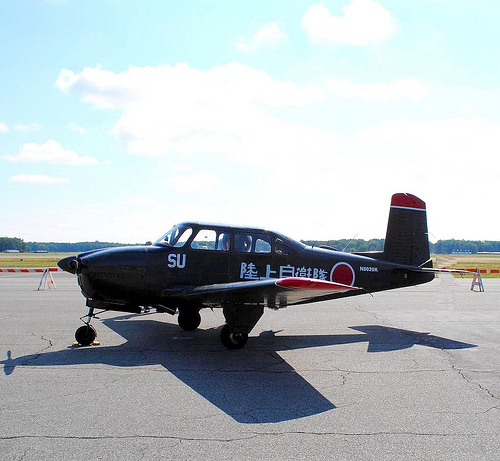Can you describe what you see in the image? This image depicts a small aircraft on a runway under a mostly clear sky with some clouds drifting in the background. What kind of use do you think this plane has? This aircraft appears to be designed for military training purposes, likely used for pilot training due to its structure and markings. If this plane could talk, what would it say about its daily routine? 'Every day, I soar through the skies, mastering loops and turns as I train aspiring pilots. The runway is my gateway to the endless blue above, where I dance among the clouds and return with the setting sun.' 